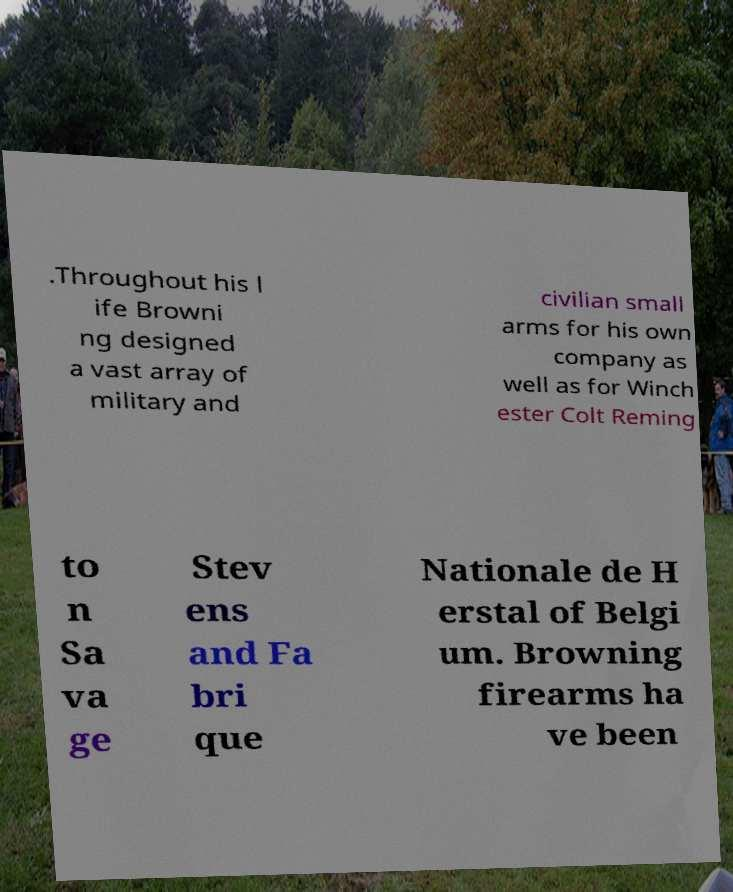I need the written content from this picture converted into text. Can you do that? .Throughout his l ife Browni ng designed a vast array of military and civilian small arms for his own company as well as for Winch ester Colt Reming to n Sa va ge Stev ens and Fa bri que Nationale de H erstal of Belgi um. Browning firearms ha ve been 